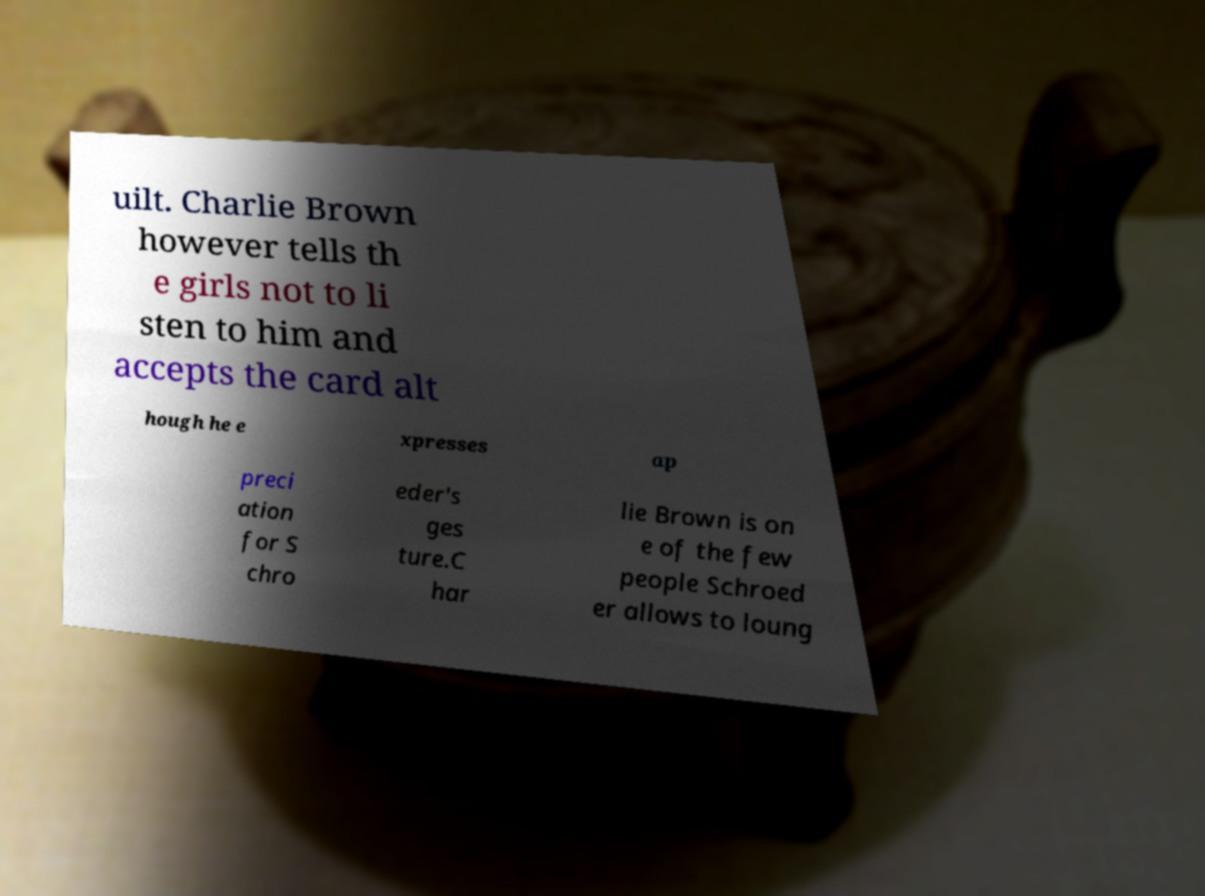Could you extract and type out the text from this image? uilt. Charlie Brown however tells th e girls not to li sten to him and accepts the card alt hough he e xpresses ap preci ation for S chro eder's ges ture.C har lie Brown is on e of the few people Schroed er allows to loung 